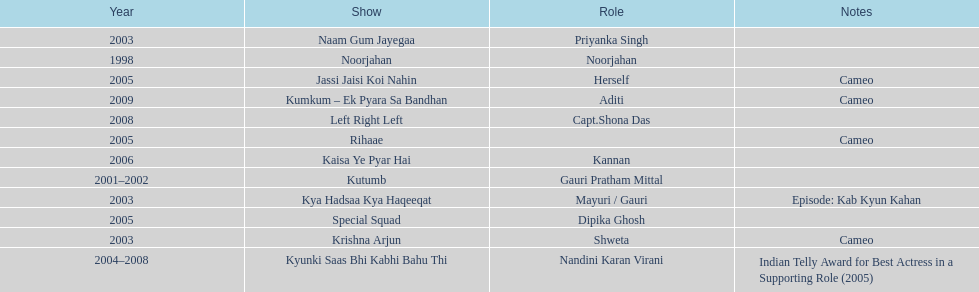How many different tv shows was gauri tejwani in before 2000? 1. 